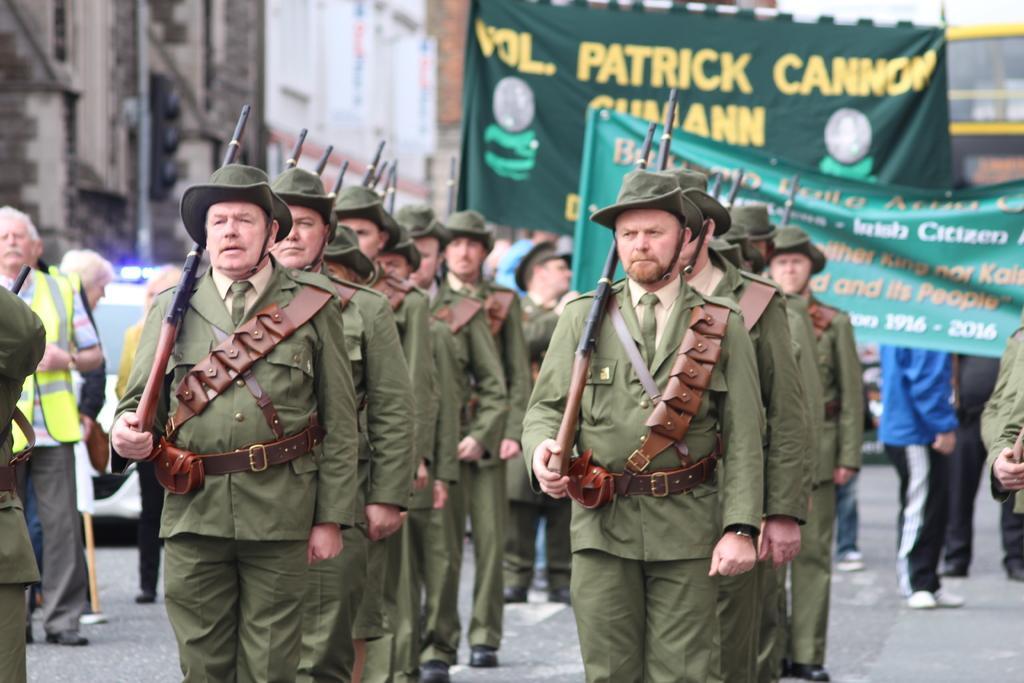In one or two sentences, can you explain what this image depicts? In the foreground of this image, there are men standing in lines holding guns on the road. Behind them, there are people holding banners. On the left, there are people and a car on the road. At the top, it seems like buildings and a pole. 